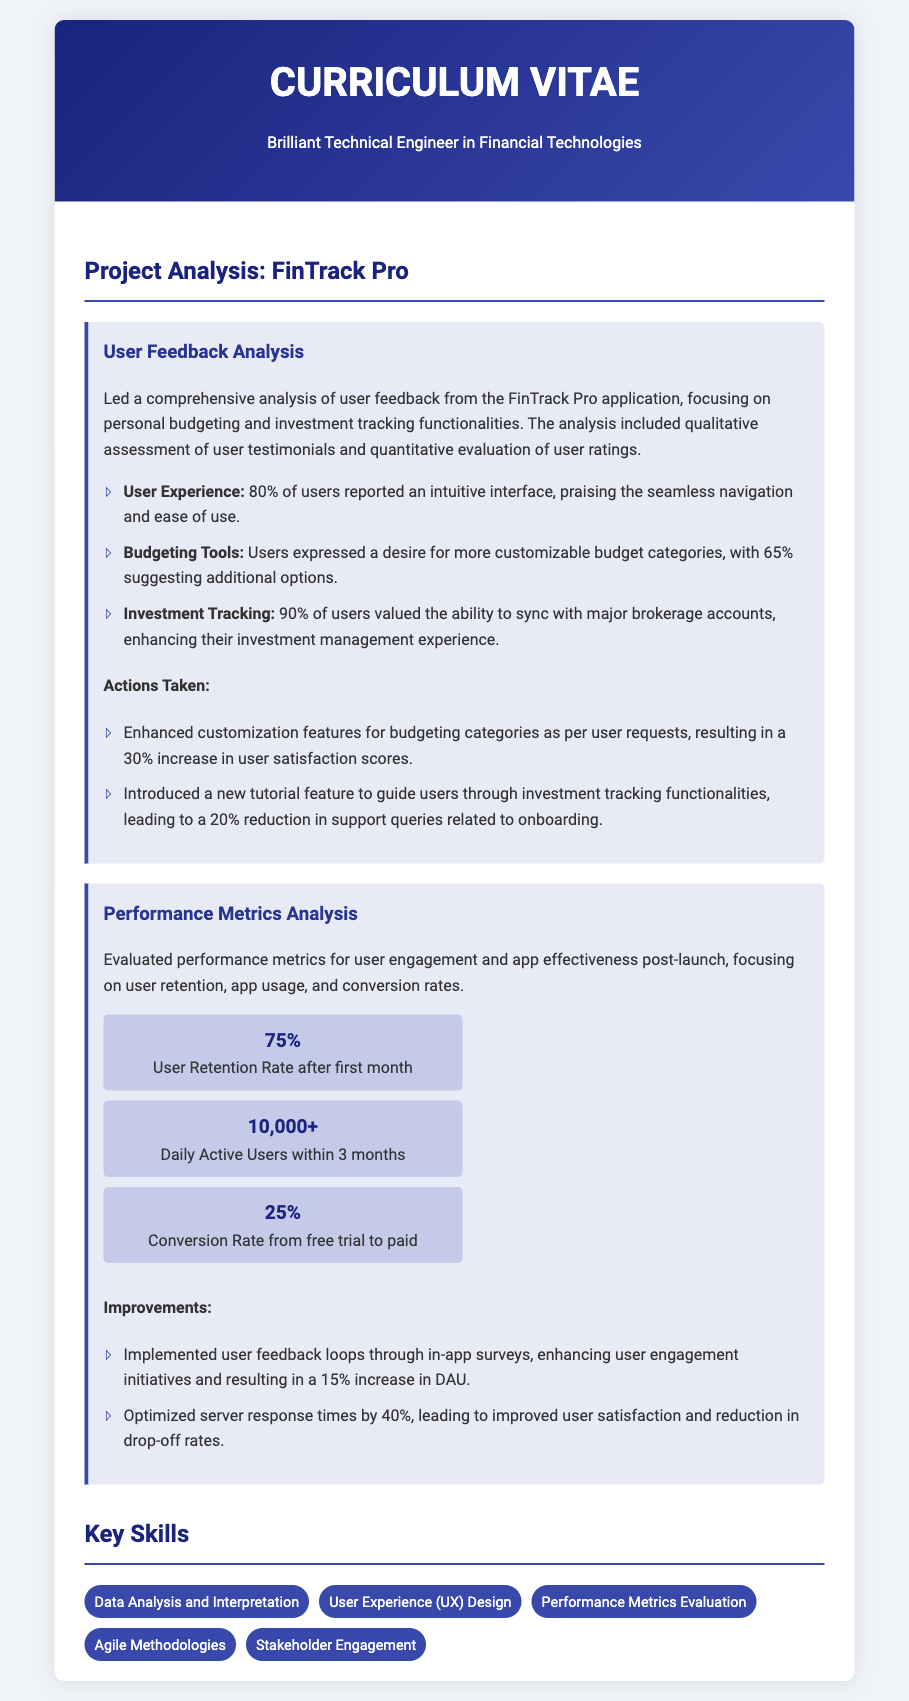What is the project name? The project is named "FinTrack Pro," which is highlighted in the title of the project analysis section.
Answer: FinTrack Pro What percentage of users reported an intuitive interface? The document states that 80% of users reported an intuitive interface in the user feedback analysis section.
Answer: 80% What action was taken to enhance user satisfaction scores? The document mentions that the customization features for budgeting categories were enhanced, resulting in a 30% increase in user satisfaction scores.
Answer: 30% What is the user retention rate after the first month? The user retention rate after the first month, as detailed in the performance metrics analysis, is 75%.
Answer: 75% How many daily active users were there within three months? The performance metrics indicate that there were over 10,000 daily active users within three months of the launch.
Answer: 10,000+ What percentage of users valued the ability to sync with brokerage accounts? According to user feedback analysis, 90% of users valued the ability to sync with major brokerage accounts.
Answer: 90% What improvement led to a 15% increase in daily active users? The implementation of user feedback loops through in-app surveys enhanced user engagement initiatives, resulting in a 15% increase in daily active users.
Answer: 15% Which skill focuses on understanding both qualitative and quantitative data? The skill "Data Analysis and Interpretation" focuses on understanding both qualitative and quantitative data, as mentioned in the key skills section.
Answer: Data Analysis and Interpretation What feedback mechanism was introduced to enhance user engagement? The document states that in-app surveys were implemented as a feedback mechanism to enhance user engagement initiatives.
Answer: in-app surveys 